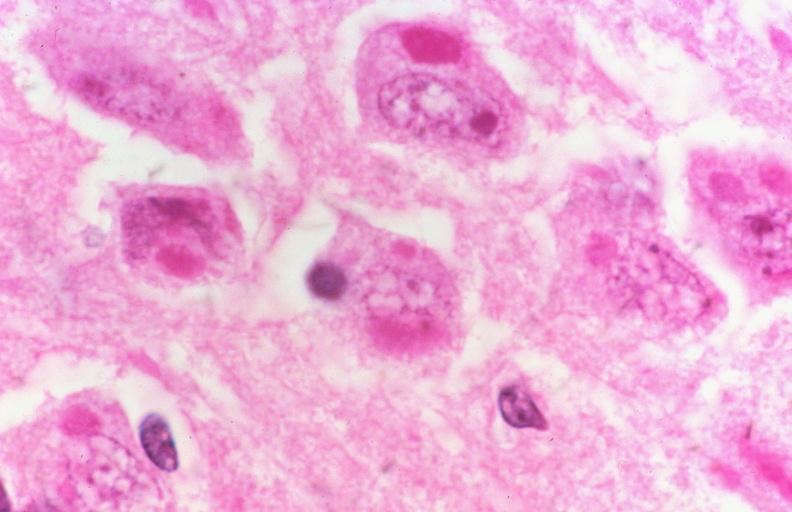s nervous present?
Answer the question using a single word or phrase. Yes 